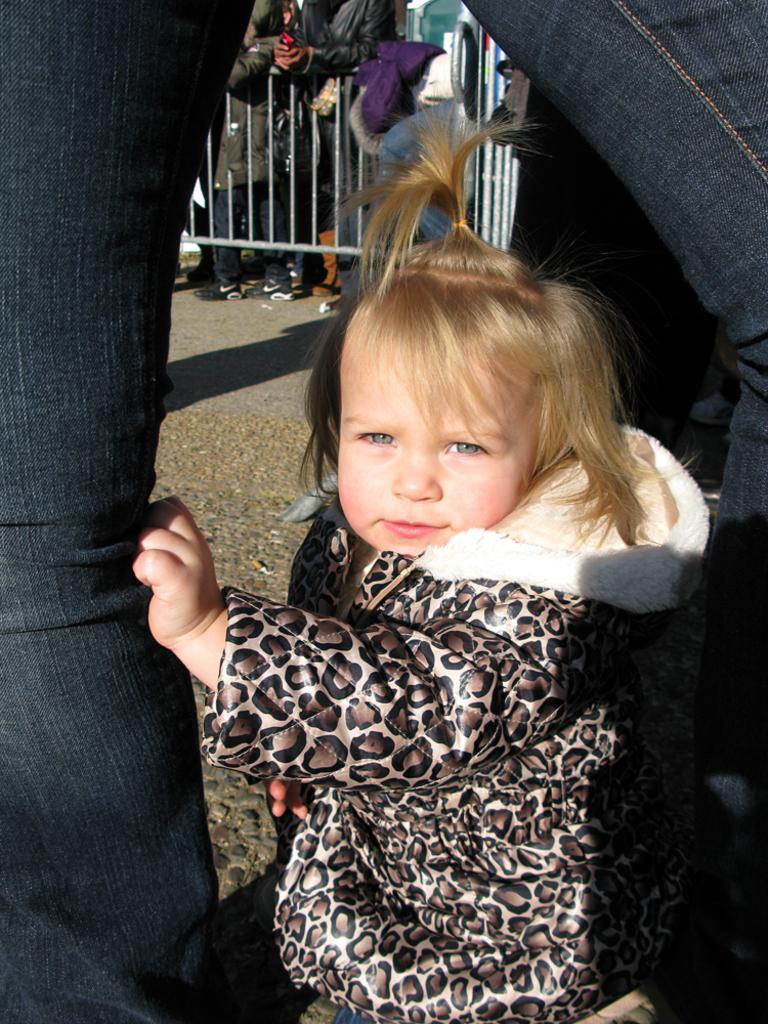Please provide a concise description of this image. In this image we can see few people. There is a barrier in the image. 